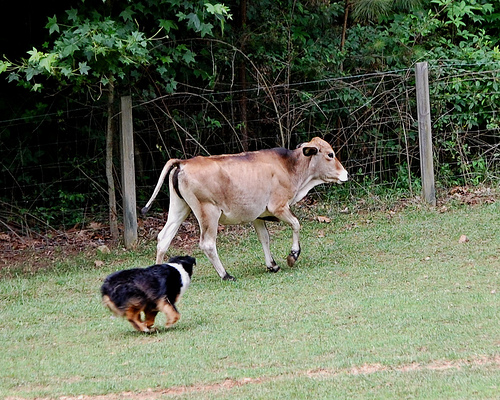<image>Is it morning time in this picture? I am not sure if it is morning time in the picture. Is it morning time in this picture? I don't know if it is morning time in this picture. It can be both morning or not. 